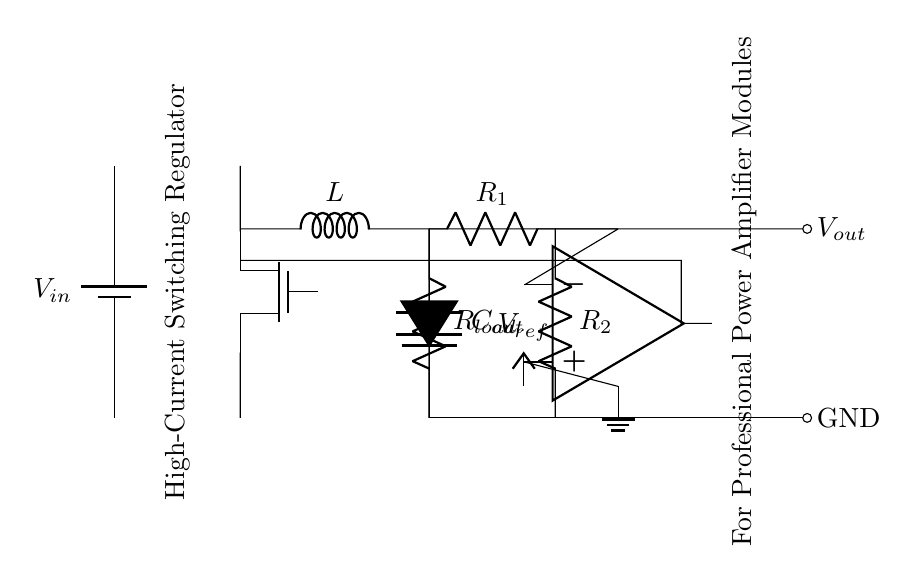What is the input voltage of the circuit? The input voltage, represented as V_in, is denoted at the battery symbol on the left side of the diagram.
Answer: V_in What type of transistor is used in this circuit? The circuit uses a switching MOSFET, identified by the symbol for a N-channel MOSFET (Tnmos) inside the diagram.
Answer: MOSFET What is the role of the inductor in this regulator circuit? The inductor is responsible for storing energy and smoothing the current output in the switching regulator, which is crucial for providing stable voltage to the load.
Answer: Energy storage How does the output voltage relate to the feedback network? The feedback network comprised of resistors R_1 and R_2 adjusts the output voltage by feeding back a portion of the output voltage to the error amplifier, ensuring steady regulation based on the reference voltage.
Answer: Regulation What is the purpose of the error amplifier in this circuit? The error amplifier compares the feedback voltage (from the load via R_1 and R_2) to a reference voltage (V_ref) to maintain the output voltage at the desired level despite load variations.
Answer: Compare voltages What is the output voltage of this regulator circuit? The output voltage V_out is referenced at the rightmost terminal of the circuit, showing the final voltage provided to the load and is generally defined as the regulated output.
Answer: V_out What components are present in the output circuit? The output circuit consists of a load resistor (R_load) and an output capacitor (C_out), both crucial for ensuring stable output performance.
Answer: Resistor and capacitor 